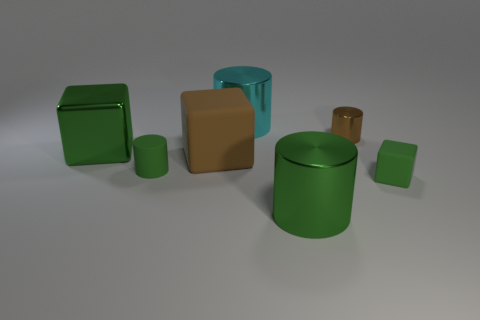Subtract all big green cubes. How many cubes are left? 2 Subtract all purple balls. How many green cubes are left? 2 Subtract 1 cylinders. How many cylinders are left? 3 Subtract all brown cylinders. How many cylinders are left? 3 Subtract all blocks. How many objects are left? 4 Add 3 matte cubes. How many objects exist? 10 Subtract all red blocks. Subtract all gray cylinders. How many blocks are left? 3 Subtract 2 green cylinders. How many objects are left? 5 Subtract all gray rubber spheres. Subtract all brown metallic things. How many objects are left? 6 Add 3 brown matte blocks. How many brown matte blocks are left? 4 